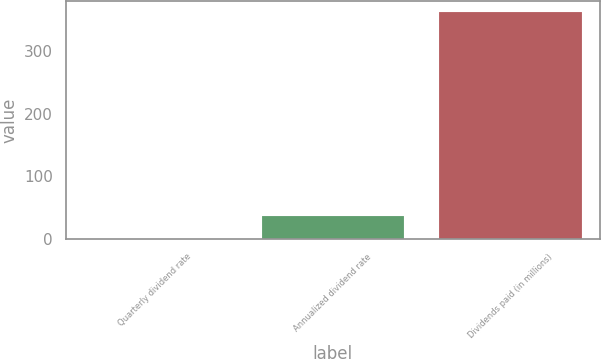Convert chart. <chart><loc_0><loc_0><loc_500><loc_500><bar_chart><fcel>Quarterly dividend rate<fcel>Annualized dividend rate<fcel>Dividends paid (in millions)<nl><fcel>0.33<fcel>36.6<fcel>363<nl></chart> 